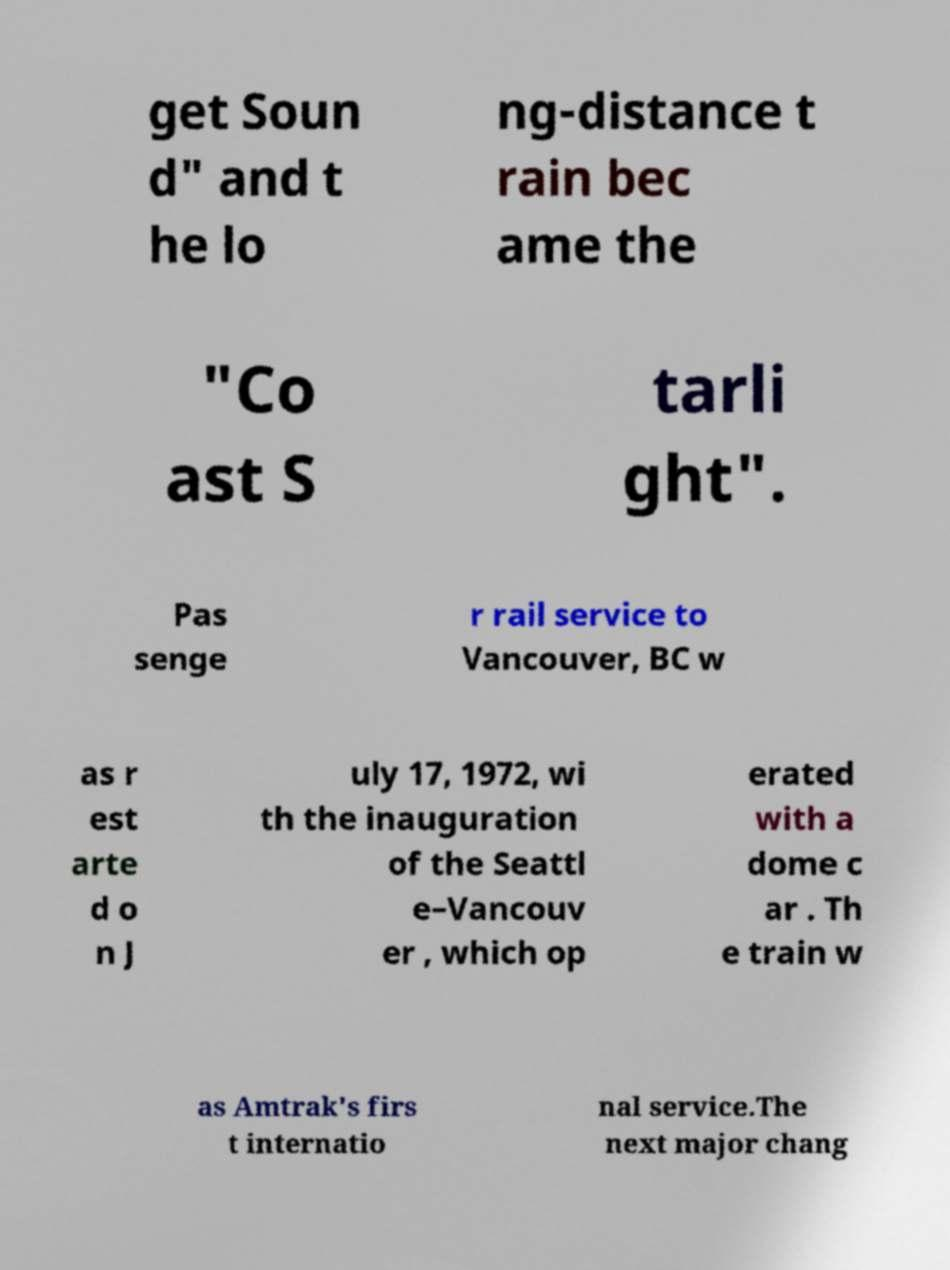Can you accurately transcribe the text from the provided image for me? get Soun d" and t he lo ng-distance t rain bec ame the "Co ast S tarli ght". Pas senge r rail service to Vancouver, BC w as r est arte d o n J uly 17, 1972, wi th the inauguration of the Seattl e–Vancouv er , which op erated with a dome c ar . Th e train w as Amtrak's firs t internatio nal service.The next major chang 